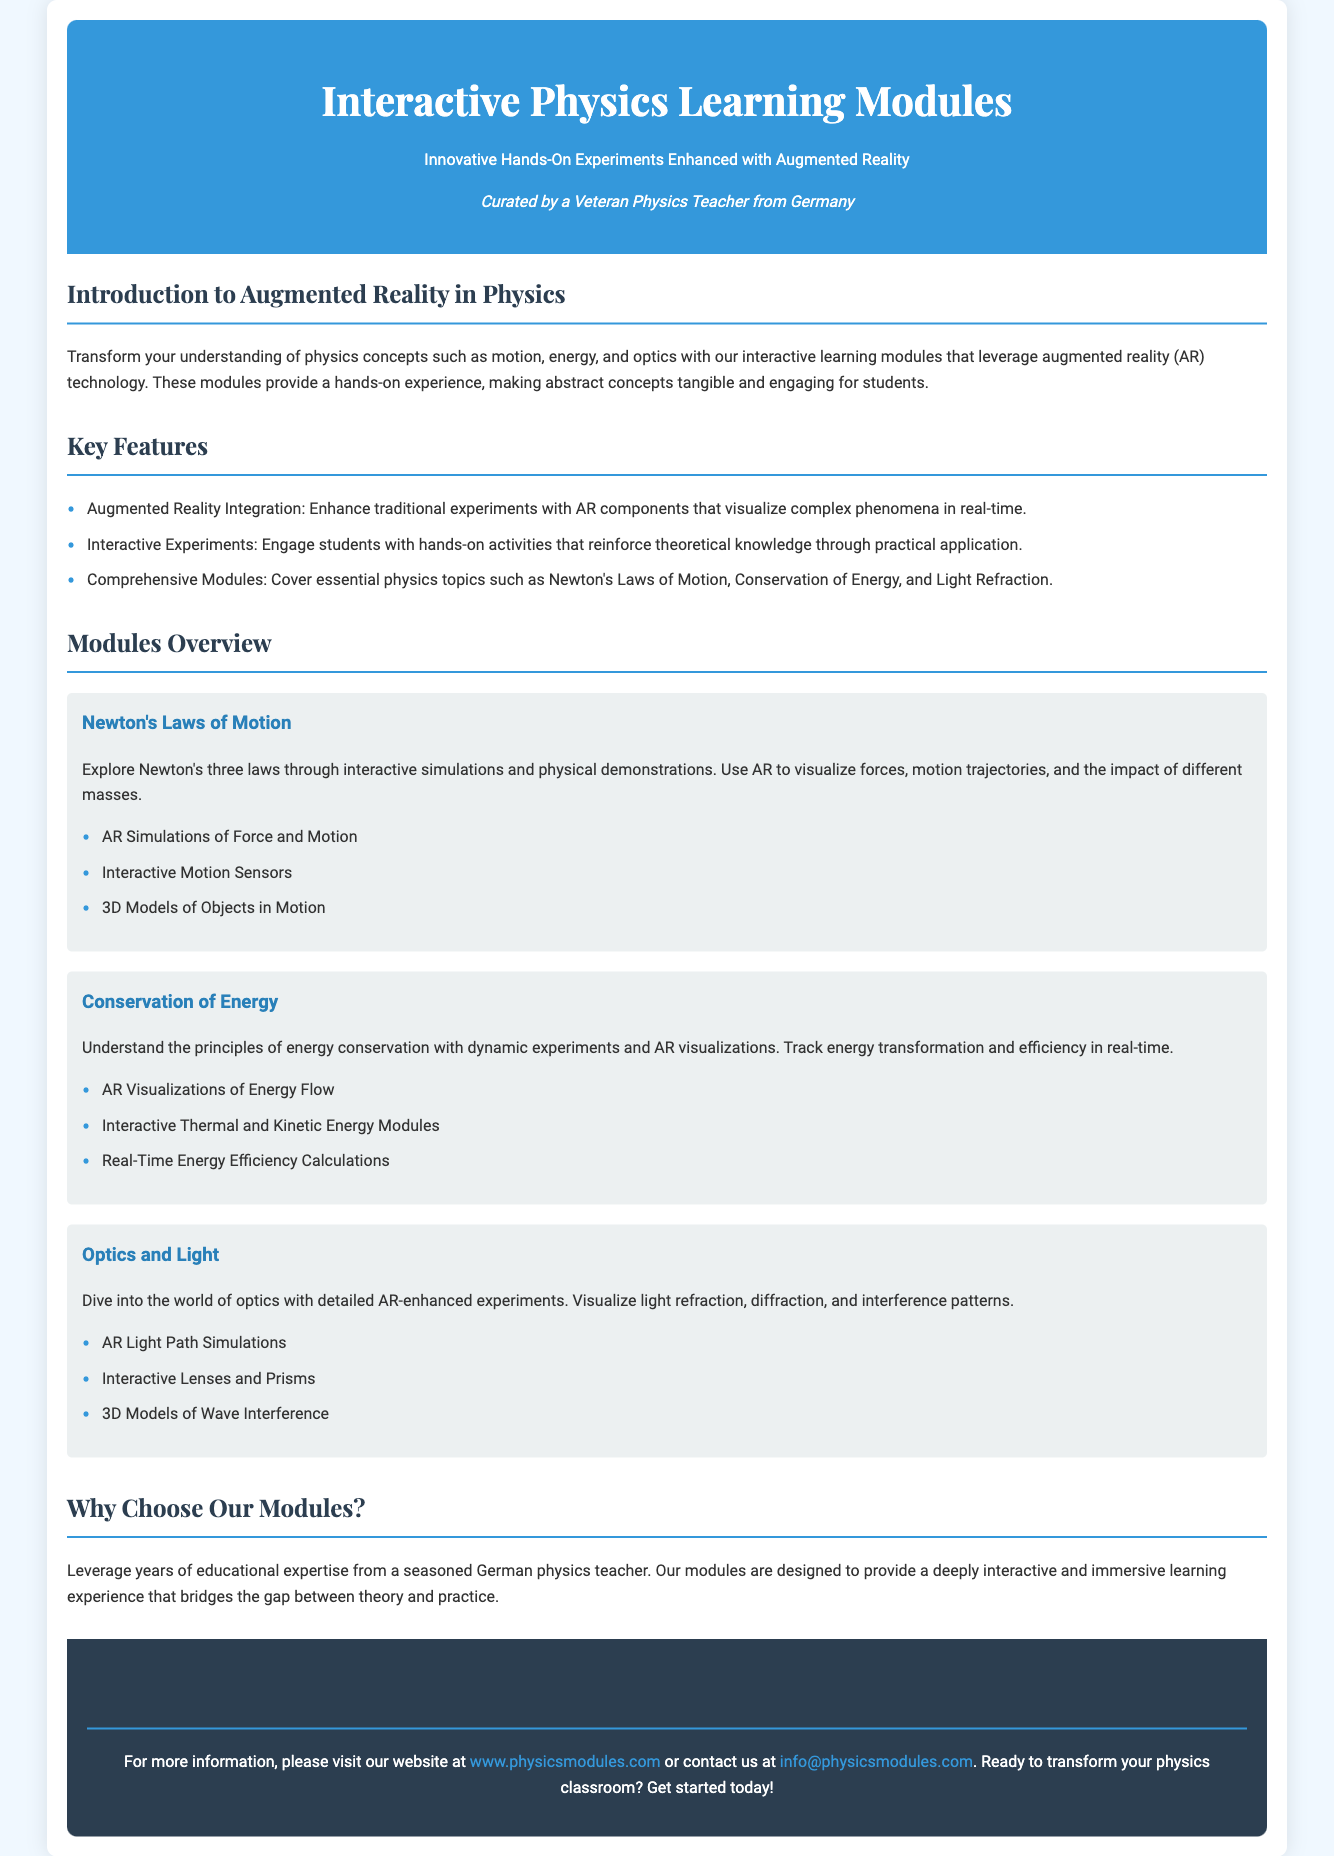What is the tagline for the modules? The tagline is a phrase that encapsulates the essence of the product and is found in the header section of the document.
Answer: Innovative Hands-On Experiments Enhanced with Augmented Reality How many modules are outlined in the overview? The overview lists specific physics topics, with each module corresponding to a topic, allowing for counting.
Answer: Three What technology is integrated into the learning modules? The document specifically mentions this technology as a feature that enhances the learning experience.
Answer: Augmented Reality Which physics concept is explored in the first module? Each module focuses on a specific physics principle, and this is the first one listed in the 'Modules Overview'.
Answer: Newton's Laws of Motion What is one of the properties students can track in the Conservation of Energy module? This property is a key aspect of understanding energy principles and is mentioned in the associated description for the module.
Answer: Energy transformation Why are the modules designed for interactive learning? The document explains the motive behind interactive learning, connecting theoretical concepts with practical applications.
Answer: To bridge the gap between theory and practice What area of physics does the third module focus on? This question asks for the specific subject matter of the module, which is clearly stated in the overview.
Answer: Optics and Light Who curated the learning modules? The document states this individual has a professional background that supports the credibility of the modules offered.
Answer: A Veteran Physics Teacher from Germany 